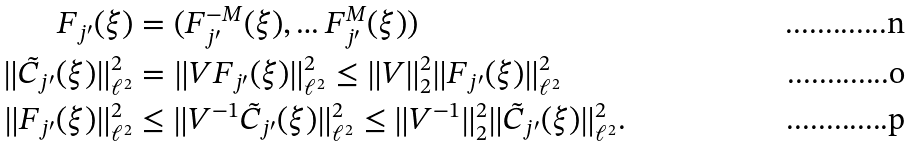<formula> <loc_0><loc_0><loc_500><loc_500>F _ { j ^ { \prime } } ( \xi ) & = ( F ^ { - M } _ { j ^ { \prime } } ( \xi ) , \hdots F ^ { M } _ { j ^ { \prime } } ( \xi ) ) \\ \| \tilde { C } _ { j ^ { \prime } } ( \xi ) \| _ { \ell ^ { 2 } } ^ { 2 } & = \| V F _ { j ^ { \prime } } ( \xi ) \| _ { \ell ^ { 2 } } ^ { 2 } \leq \| V \| _ { 2 } ^ { 2 } \| F _ { j ^ { \prime } } ( \xi ) \| _ { \ell ^ { 2 } } ^ { 2 } \\ \| F _ { j ^ { \prime } } ( \xi ) \| _ { \ell ^ { 2 } } ^ { 2 } & \leq \| V ^ { - 1 } \tilde { C } _ { j ^ { \prime } } ( \xi ) \| _ { \ell ^ { 2 } } ^ { 2 } \leq \| V ^ { - 1 } \| _ { 2 } ^ { 2 } \| \tilde { C } _ { j ^ { \prime } } ( \xi ) \| _ { \ell ^ { 2 } } ^ { 2 } .</formula> 